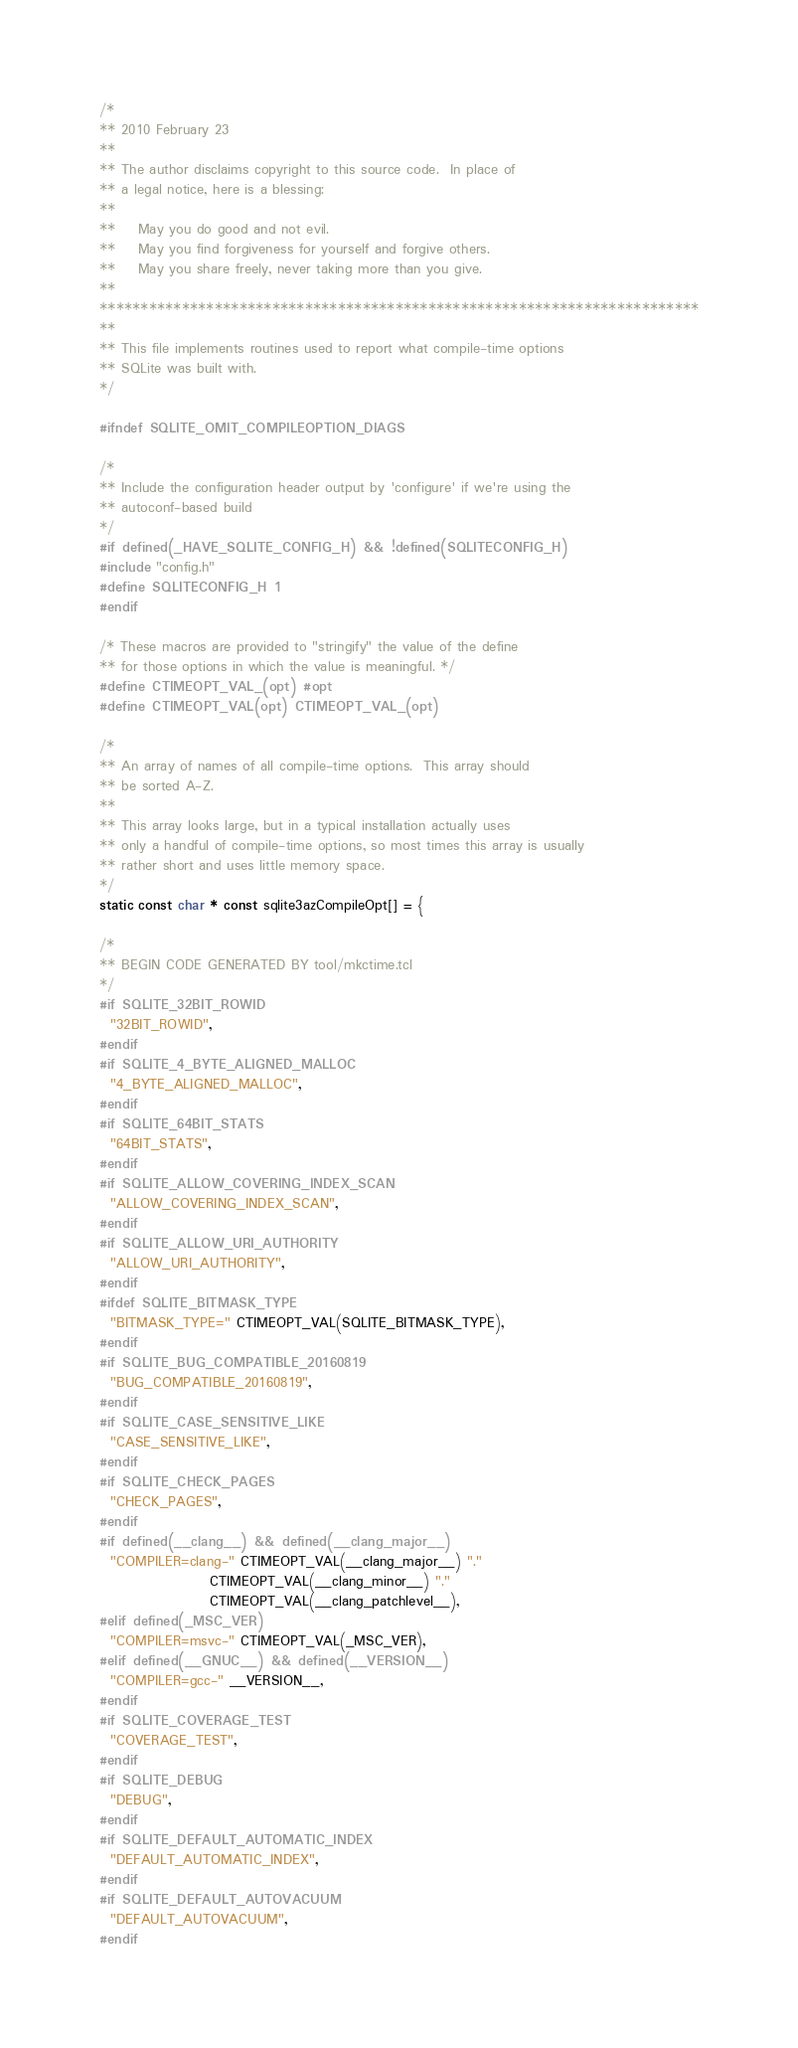Convert code to text. <code><loc_0><loc_0><loc_500><loc_500><_C_>/*
** 2010 February 23
**
** The author disclaims copyright to this source code.  In place of
** a legal notice, here is a blessing:
**
**    May you do good and not evil.
**    May you find forgiveness for yourself and forgive others.
**    May you share freely, never taking more than you give.
**
*************************************************************************
**
** This file implements routines used to report what compile-time options
** SQLite was built with.
*/

#ifndef SQLITE_OMIT_COMPILEOPTION_DIAGS

/*
** Include the configuration header output by 'configure' if we're using the
** autoconf-based build
*/
#if defined(_HAVE_SQLITE_CONFIG_H) && !defined(SQLITECONFIG_H)
#include "config.h"
#define SQLITECONFIG_H 1
#endif

/* These macros are provided to "stringify" the value of the define
** for those options in which the value is meaningful. */
#define CTIMEOPT_VAL_(opt) #opt
#define CTIMEOPT_VAL(opt) CTIMEOPT_VAL_(opt)

/*
** An array of names of all compile-time options.  This array should 
** be sorted A-Z.
**
** This array looks large, but in a typical installation actually uses
** only a handful of compile-time options, so most times this array is usually
** rather short and uses little memory space.
*/
static const char * const sqlite3azCompileOpt[] = {

/* 
** BEGIN CODE GENERATED BY tool/mkctime.tcl 
*/
#if SQLITE_32BIT_ROWID
  "32BIT_ROWID",
#endif
#if SQLITE_4_BYTE_ALIGNED_MALLOC
  "4_BYTE_ALIGNED_MALLOC",
#endif
#if SQLITE_64BIT_STATS
  "64BIT_STATS",
#endif
#if SQLITE_ALLOW_COVERING_INDEX_SCAN
  "ALLOW_COVERING_INDEX_SCAN",
#endif
#if SQLITE_ALLOW_URI_AUTHORITY
  "ALLOW_URI_AUTHORITY",
#endif
#ifdef SQLITE_BITMASK_TYPE
  "BITMASK_TYPE=" CTIMEOPT_VAL(SQLITE_BITMASK_TYPE),
#endif
#if SQLITE_BUG_COMPATIBLE_20160819
  "BUG_COMPATIBLE_20160819",
#endif
#if SQLITE_CASE_SENSITIVE_LIKE
  "CASE_SENSITIVE_LIKE",
#endif
#if SQLITE_CHECK_PAGES
  "CHECK_PAGES",
#endif
#if defined(__clang__) && defined(__clang_major__)
  "COMPILER=clang-" CTIMEOPT_VAL(__clang_major__) "."
                    CTIMEOPT_VAL(__clang_minor__) "."
                    CTIMEOPT_VAL(__clang_patchlevel__),
#elif defined(_MSC_VER)
  "COMPILER=msvc-" CTIMEOPT_VAL(_MSC_VER),
#elif defined(__GNUC__) && defined(__VERSION__)
  "COMPILER=gcc-" __VERSION__,
#endif
#if SQLITE_COVERAGE_TEST
  "COVERAGE_TEST",
#endif
#if SQLITE_DEBUG
  "DEBUG",
#endif
#if SQLITE_DEFAULT_AUTOMATIC_INDEX
  "DEFAULT_AUTOMATIC_INDEX",
#endif
#if SQLITE_DEFAULT_AUTOVACUUM
  "DEFAULT_AUTOVACUUM",
#endif</code> 